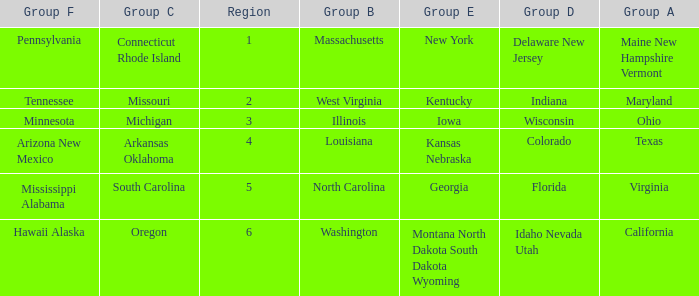What is the group B region with a Group E region of Georgia? North Carolina. 